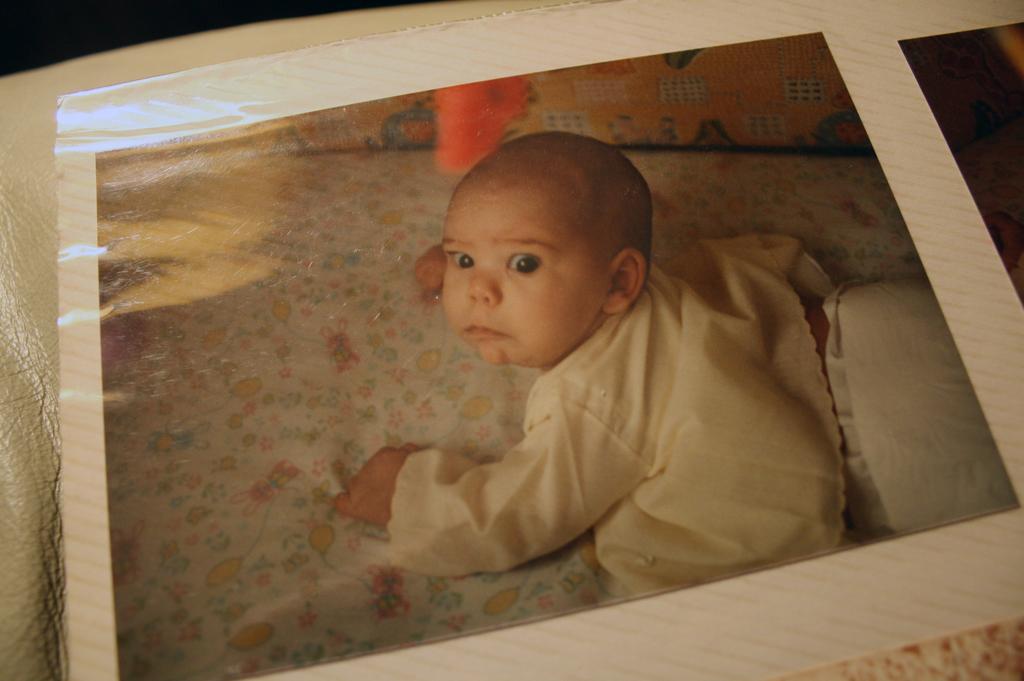Can you describe this image briefly? In the image we can see a photograph of the baby lying and the baby is wearing clothes. 